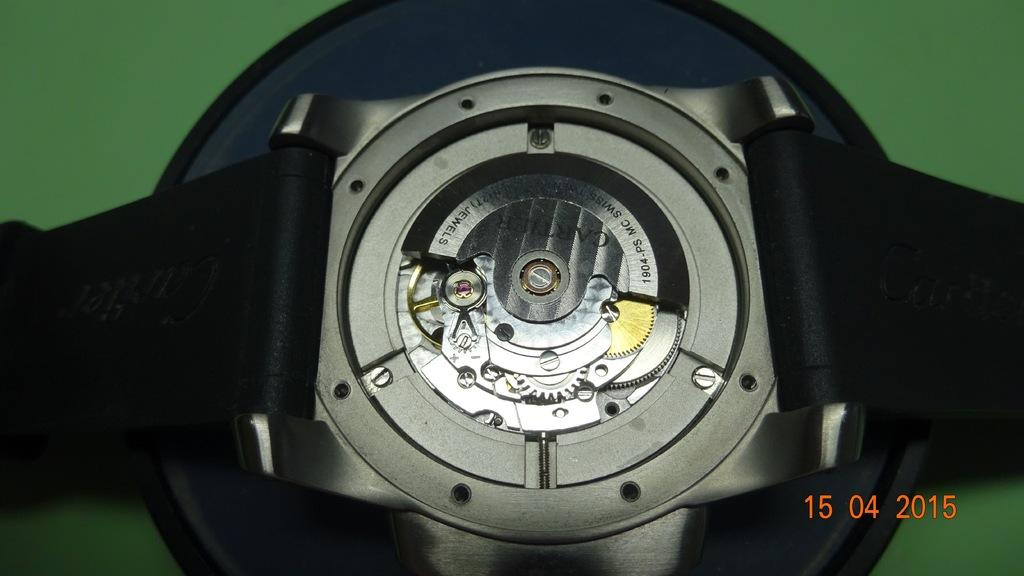<image>
Create a compact narrative representing the image presented. The mechanics of a model 1904-PS MC Swiss wrist watch. 